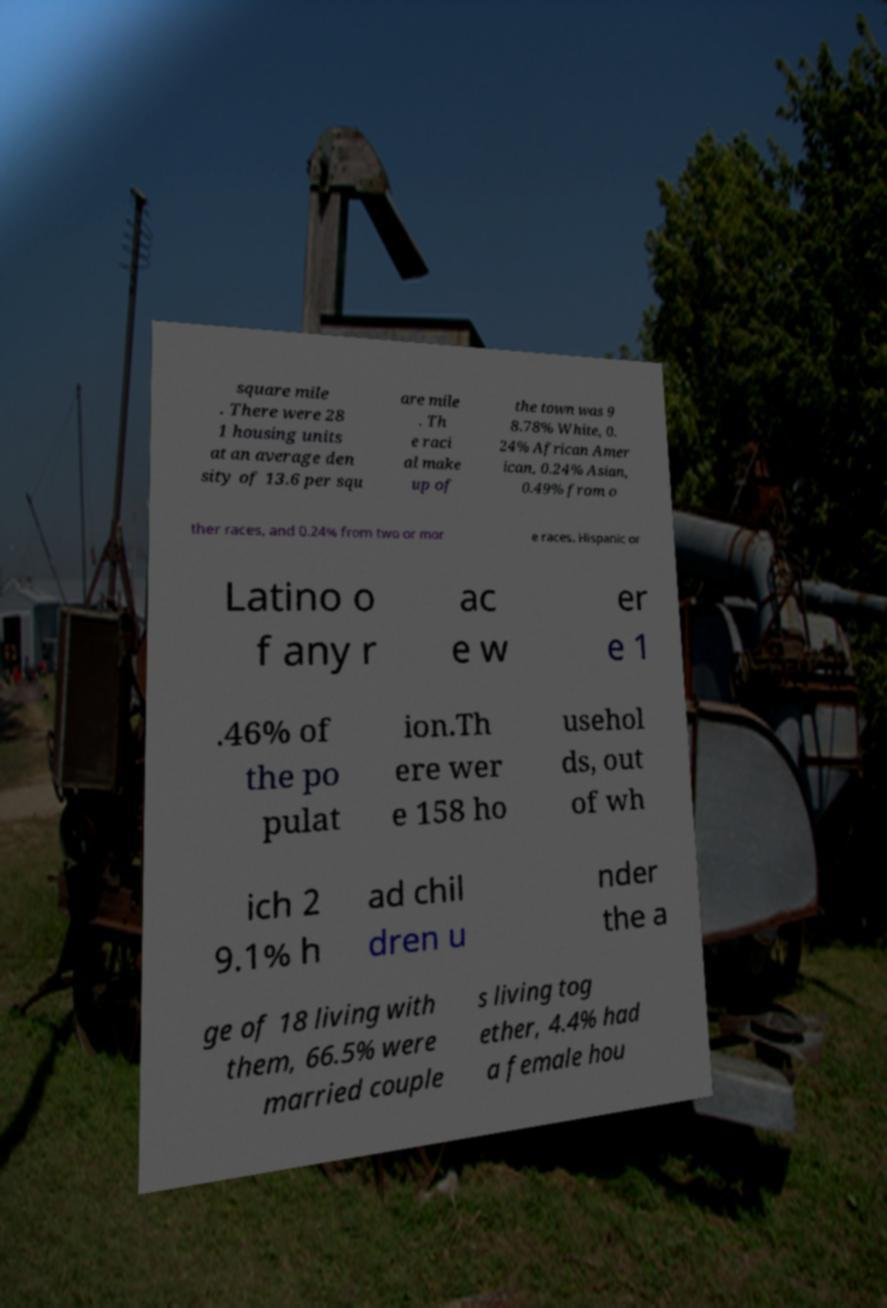Can you accurately transcribe the text from the provided image for me? square mile . There were 28 1 housing units at an average den sity of 13.6 per squ are mile . Th e raci al make up of the town was 9 8.78% White, 0. 24% African Amer ican, 0.24% Asian, 0.49% from o ther races, and 0.24% from two or mor e races. Hispanic or Latino o f any r ac e w er e 1 .46% of the po pulat ion.Th ere wer e 158 ho usehol ds, out of wh ich 2 9.1% h ad chil dren u nder the a ge of 18 living with them, 66.5% were married couple s living tog ether, 4.4% had a female hou 